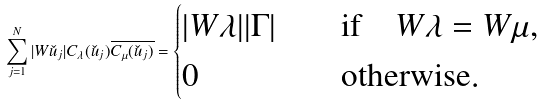<formula> <loc_0><loc_0><loc_500><loc_500>\sum _ { j = 1 } ^ { N } | W \check { u } _ { j } | C _ { \lambda } ( \check { u } _ { j } ) \overline { C _ { \mu } ( \check { u } _ { j } ) } = \begin{cases} | W \lambda | | \Gamma | \quad & \text {if} \quad W \lambda = W \mu , \\ 0 \quad & \text {otherwise} . \end{cases}</formula> 